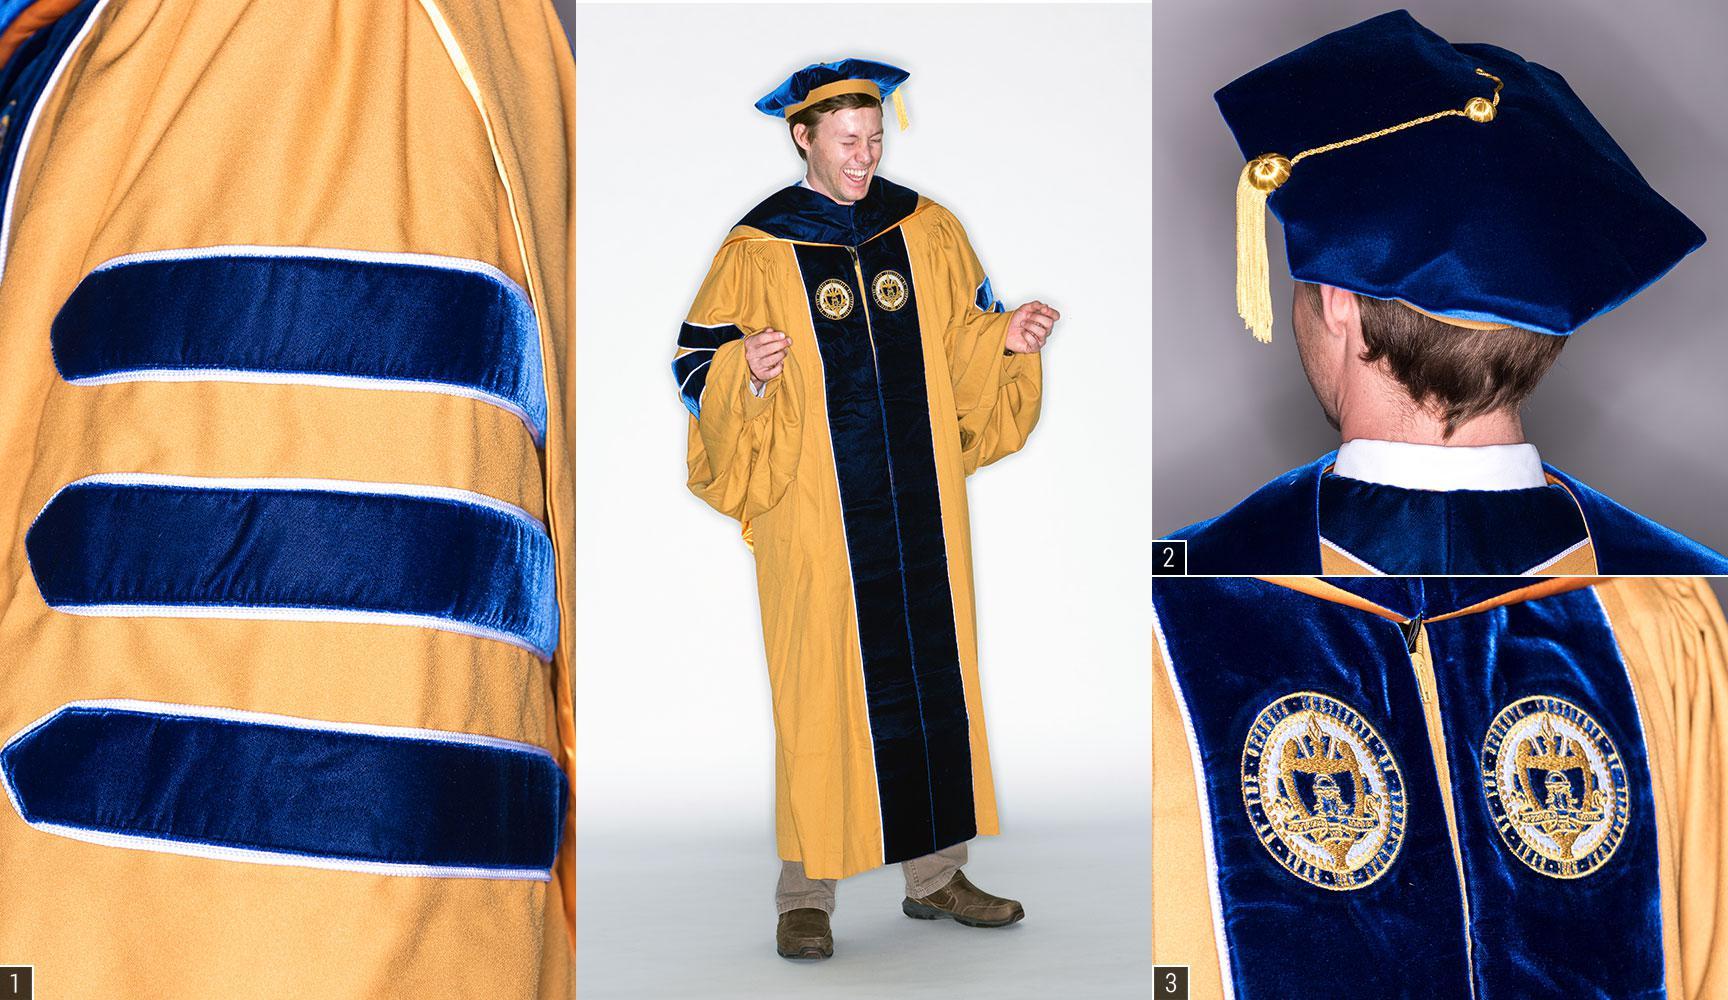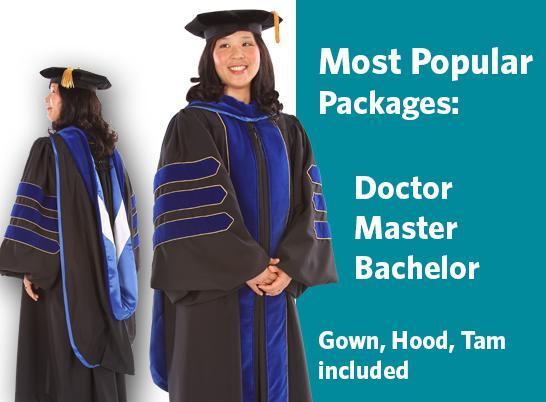The first image is the image on the left, the second image is the image on the right. Analyze the images presented: Is the assertion "An image of a group of graduates includes a female with red hair and back turned to the camera." valid? Answer yes or no. No. The first image is the image on the left, the second image is the image on the right. Analyze the images presented: Is the assertion "There are two people in every image wearing graduation caps." valid? Answer yes or no. Yes. 